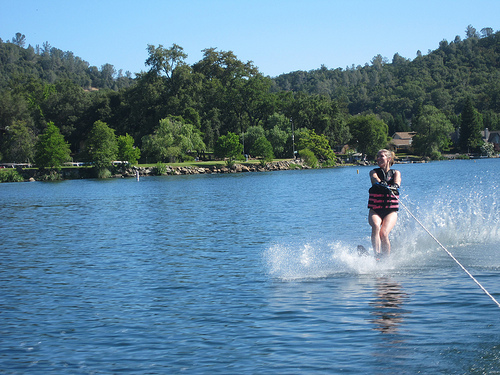How many people are there? 1 